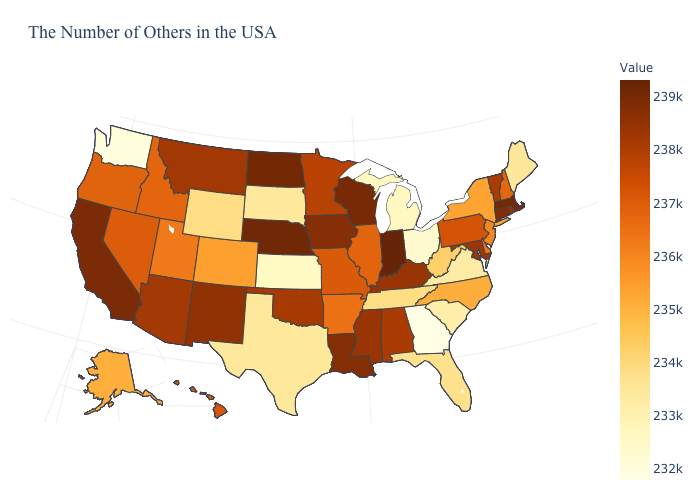Among the states that border Utah , does Colorado have the highest value?
Short answer required. No. Among the states that border Washington , which have the lowest value?
Be succinct. Idaho. Among the states that border North Carolina , which have the highest value?
Keep it brief. Tennessee. Does Washington have the highest value in the USA?
Be succinct. No. Does Georgia have the lowest value in the USA?
Short answer required. Yes. 